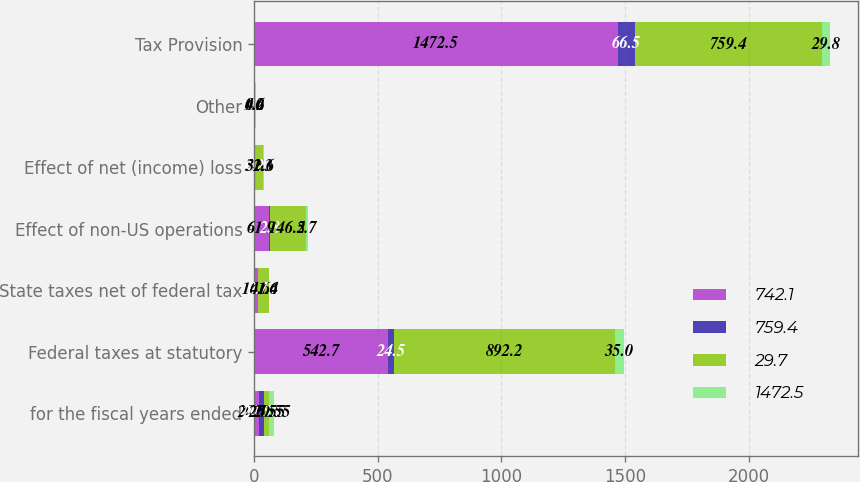Convert chart to OTSL. <chart><loc_0><loc_0><loc_500><loc_500><stacked_bar_chart><ecel><fcel>for the fiscal years ended<fcel>Federal taxes at statutory<fcel>State taxes net of federal tax<fcel>Effect of non-US operations<fcel>Effect of net (income) loss<fcel>Other<fcel>Tax Provision<nl><fcel>742.1<fcel>20.55<fcel>542.7<fcel>16.6<fcel>61.9<fcel>5.3<fcel>1<fcel>1472.5<nl><fcel>759.4<fcel>20.55<fcel>24.5<fcel>0.7<fcel>2.8<fcel>0.2<fcel>0.1<fcel>66.5<nl><fcel>29.7<fcel>20.55<fcel>892.2<fcel>41.4<fcel>146.2<fcel>32.6<fcel>4.6<fcel>759.4<nl><fcel>1472.5<fcel>20.55<fcel>35<fcel>1.6<fcel>5.7<fcel>1.3<fcel>0.2<fcel>29.8<nl></chart> 